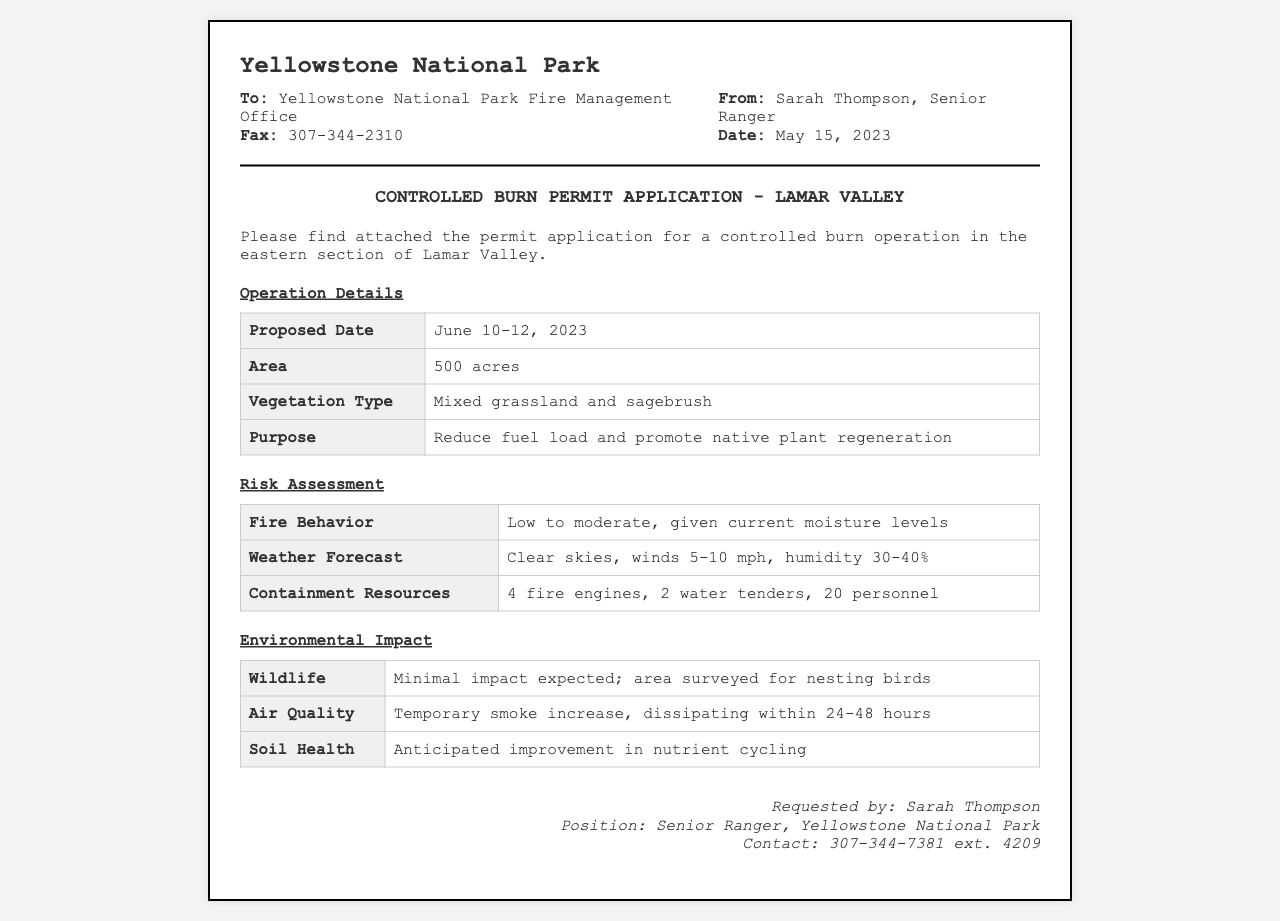What is the proposed date for the controlled burn? The proposed date is stated clearly in the document under "Operation Details."
Answer: June 10-12, 2023 What is the area designated for the controlled burn? The area is specified in the table under "Operation Details."
Answer: 500 acres Who is the sender of the fax? The sender's name is provided at the top of the fax in the "From" section.
Answer: Sarah Thompson What type of vegetation is present in the burn area? This information is listed in the "Operation Details" section of the document.
Answer: Mixed grassland and sagebrush What is one purpose of the controlled burn? The purpose is mentioned in the "Operation Details" section.
Answer: Reduce fuel load and promote native plant regeneration What is the expected weather forecast for the burn operation? The weather forecast is included in the "Risk Assessment" section.
Answer: Clear skies, winds 5-10 mph, humidity 30-40% How many personnel are allocated for containment resources? The number of personnel is detailed in the "Risk Assessment" section.
Answer: 20 personnel What is the anticipated impact on soil health? This information can be found in the "Environmental Impact" section of the document.
Answer: Anticipated improvement in nutrient cycling What is the contact number for Sarah Thompson? The contact number is provided in the footer of the fax.
Answer: 307-344-7381 ext. 4209 